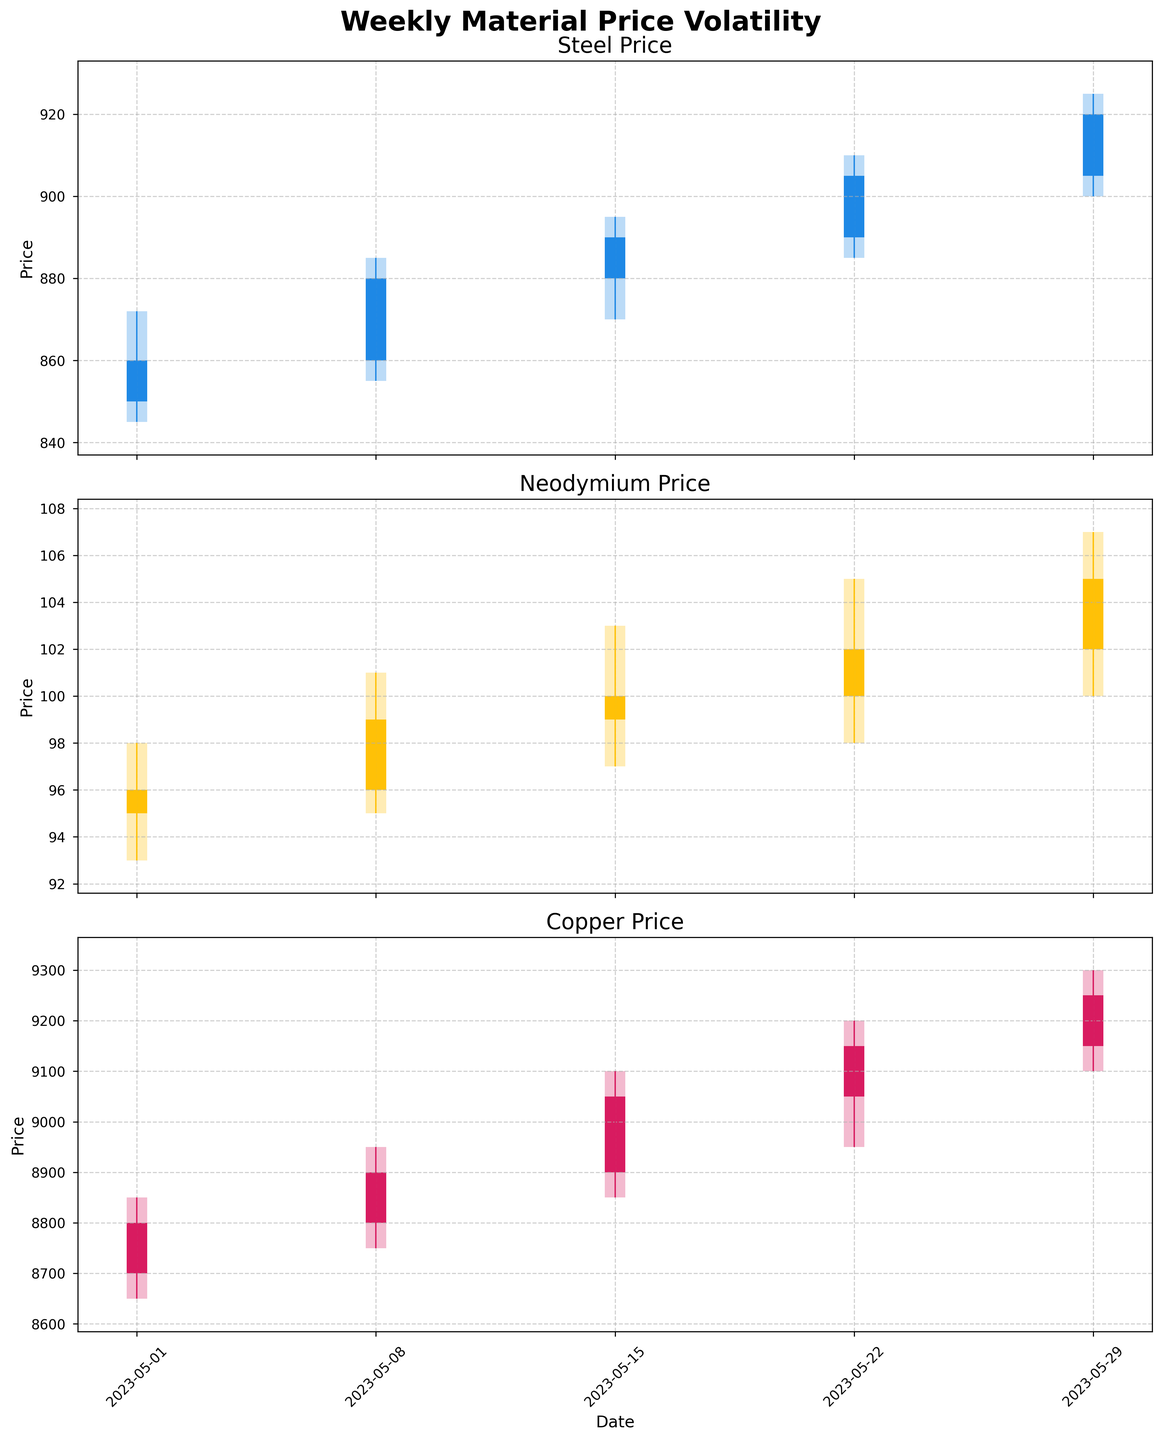What is the title of the figure? The title is located at the top of the figure and provides an overall description of what is being displayed. It is "Weekly Material Price Volatility".
Answer: Weekly Material Price Volatility Which material has the highest closing price on May 29, 2023? From the three materials, we look at the last date (May 29, 2023). The closing prices are: Steel (920), Neodymium (105), and Copper (925). Copper has the highest closing price.
Answer: Copper How many data points are plotted for each material? By examining the x-axis ticks and confirming with the data, each material has data points corresponding to 5 weeks in May 2023.
Answer: 5 What is the highest price recorded for Neodymium? Review the "High" prices for Neodymium across all the weeks. The highest recorded value is 107 on May 29, 2023.
Answer: 107 Did the price of Steel close higher or lower than it opened on May 22, 2023? Check the 'Open' and 'Close' prices for Steel on May 22, 2023. It opened at 890 and closed at 905, so it closed higher.
Answer: Higher Compare the closing prices of all materials on May 15, 2023. Which material closed at the lowest price? Examine the 'Close' prices for May 15, 2023: Steel (890), Neodymium (100), Copper (905). Steel closed at the lowest price.
Answer: Steel What is the average closing price of Copper in May 2023? Sum the closing prices of Copper for all weeks in May 2023 (8800, 8900, 9050, 9150, 9250) and divide by the number of weeks (5). The average is (8800 + 8900 + 9050 + 9150 + 9250) / 5 = 9020.
Answer: 9020 How many times did Neodymium's closing price increase week over week in May 2023? Compare the 'Close' prices week over week. Increases: May 1 to May 8 (96 to 99), May 8 to May 15 (99 to 100), May 22 to May 29 (102 to 105). It increased 3 times.
Answer: 3 Which week saw the highest volatility in Copper prices, and what was the price range for that week? Volatility can be inferred from the difference between 'High' and 'Low' prices. The week of May 15, 2023, had the greatest range (9100 - 8850 = 250).
Answer: May 15, 2023, 250 Did any material's closing price remain unchanged for any week in May 2023? Compare the 'Close' prices week by week for each material. No material had the same closing price for consecutive weeks.
Answer: No 